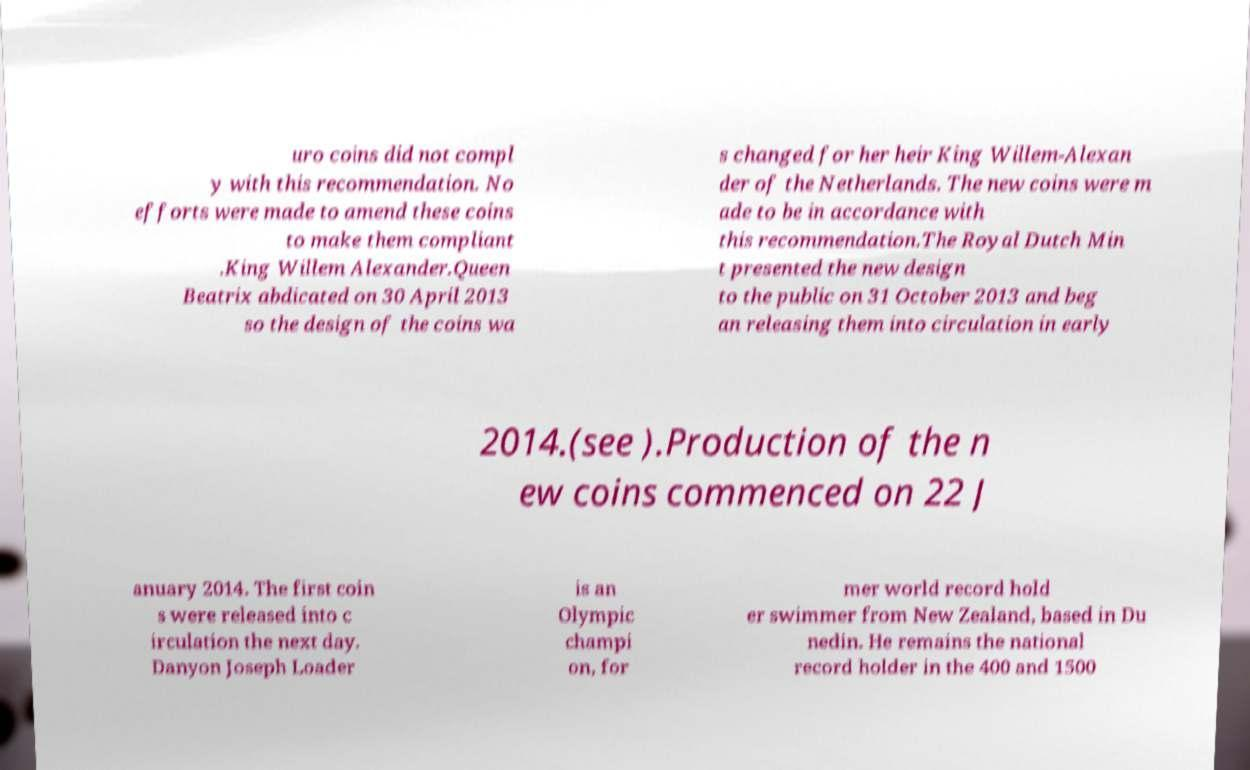Please read and relay the text visible in this image. What does it say? uro coins did not compl y with this recommendation. No efforts were made to amend these coins to make them compliant .King Willem Alexander.Queen Beatrix abdicated on 30 April 2013 so the design of the coins wa s changed for her heir King Willem-Alexan der of the Netherlands. The new coins were m ade to be in accordance with this recommendation.The Royal Dutch Min t presented the new design to the public on 31 October 2013 and beg an releasing them into circulation in early 2014.(see ).Production of the n ew coins commenced on 22 J anuary 2014. The first coin s were released into c irculation the next day. Danyon Joseph Loader is an Olympic champi on, for mer world record hold er swimmer from New Zealand, based in Du nedin. He remains the national record holder in the 400 and 1500 